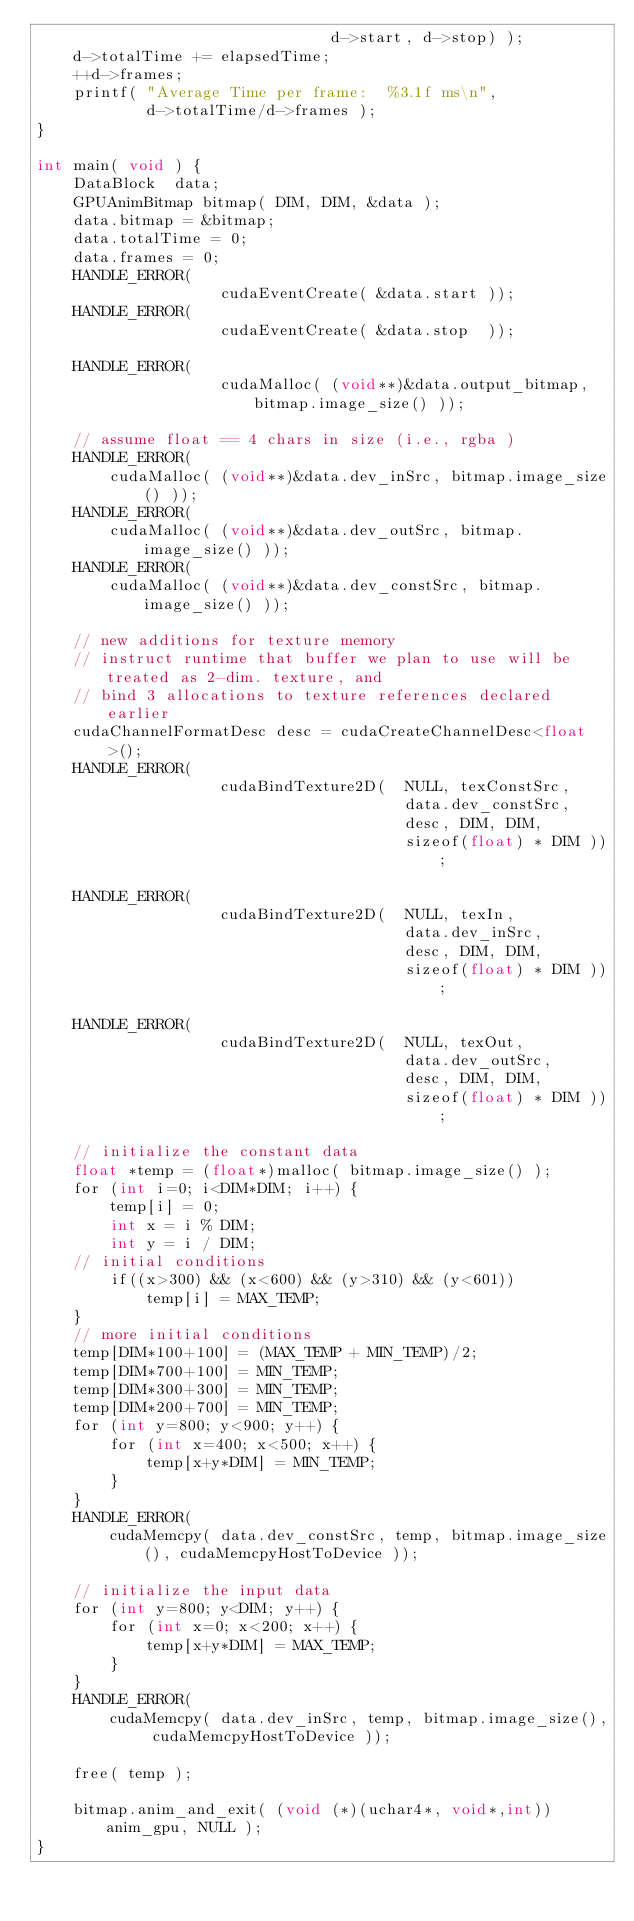Convert code to text. <code><loc_0><loc_0><loc_500><loc_500><_Cuda_>								d->start, d->stop) );
	d->totalTime += elapsedTime;
	++d->frames;
	printf( "Average Time per frame:  %3.1f ms\n",
			d->totalTime/d->frames );
}

int main( void ) {
	DataBlock  data;
	GPUAnimBitmap bitmap( DIM, DIM, &data );
	data.bitmap = &bitmap;
	data.totalTime = 0;
	data.frames = 0;
	HANDLE_ERROR(
					cudaEventCreate( &data.start ));
	HANDLE_ERROR(
					cudaEventCreate( &data.stop  ));
	
	HANDLE_ERROR(
					cudaMalloc( (void**)&data.output_bitmap, bitmap.image_size() ));
					
	// assume float == 4 chars in size (i.e., rgba )
	HANDLE_ERROR(
		cudaMalloc( (void**)&data.dev_inSrc, bitmap.image_size() ));
	HANDLE_ERROR(
		cudaMalloc( (void**)&data.dev_outSrc, bitmap.image_size() ));
	HANDLE_ERROR(
		cudaMalloc( (void**)&data.dev_constSrc, bitmap.image_size() ));

	// new additions for texture memory
	// instruct runtime that buffer we plan to use will be treated as 2-dim. texture, and 
	// bind 3 allocations to texture references declared earlier
	cudaChannelFormatDesc desc = cudaCreateChannelDesc<float>();
	HANDLE_ERROR( 
					cudaBindTexture2D(	NULL, texConstSrc,
										data.dev_constSrc,
										desc, DIM, DIM,
										sizeof(float) * DIM ));
										
	HANDLE_ERROR( 
					cudaBindTexture2D(	NULL, texIn,
										data.dev_inSrc,
										desc, DIM, DIM,
										sizeof(float) * DIM ));

	HANDLE_ERROR( 
					cudaBindTexture2D(	NULL, texOut,
										data.dev_outSrc,
										desc, DIM, DIM,
										sizeof(float) * DIM ));

	// initialize the constant data
	float *temp = (float*)malloc( bitmap.image_size() );
	for (int i=0; i<DIM*DIM; i++) {
		temp[i] = 0;
		int x = i % DIM;
		int y = i / DIM;
	// initial conditions
		if((x>300) && (x<600) && (y>310) && (y<601))
			temp[i] = MAX_TEMP;
	}
	// more initial conditions
	temp[DIM*100+100] = (MAX_TEMP + MIN_TEMP)/2;
	temp[DIM*700+100] = MIN_TEMP;
	temp[DIM*300+300] = MIN_TEMP;
	temp[DIM*200+700] = MIN_TEMP;
	for (int y=800; y<900; y++) {
		for (int x=400; x<500; x++) {
			temp[x+y*DIM] = MIN_TEMP;
		}
	}
	HANDLE_ERROR( 
		cudaMemcpy( data.dev_constSrc, temp, bitmap.image_size(), cudaMemcpyHostToDevice ));
		
	// initialize the input data	
	for (int y=800; y<DIM; y++) {
		for (int x=0; x<200; x++) {
			temp[x+y*DIM] = MAX_TEMP;
		}
	}
	HANDLE_ERROR(
		cudaMemcpy( data.dev_inSrc, temp, bitmap.image_size(), cudaMemcpyHostToDevice ));
	
	free( temp );
	
	bitmap.anim_and_exit( (void (*)(uchar4*, void*,int))anim_gpu, NULL );
}

</code> 